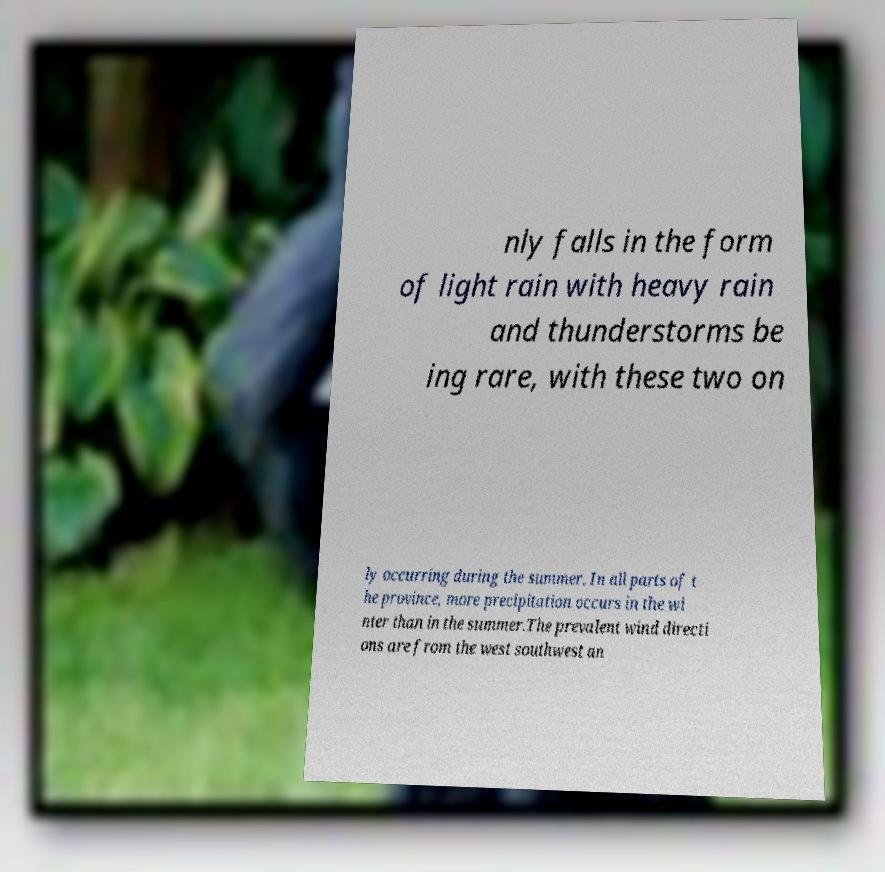There's text embedded in this image that I need extracted. Can you transcribe it verbatim? nly falls in the form of light rain with heavy rain and thunderstorms be ing rare, with these two on ly occurring during the summer. In all parts of t he province, more precipitation occurs in the wi nter than in the summer.The prevalent wind directi ons are from the west southwest an 